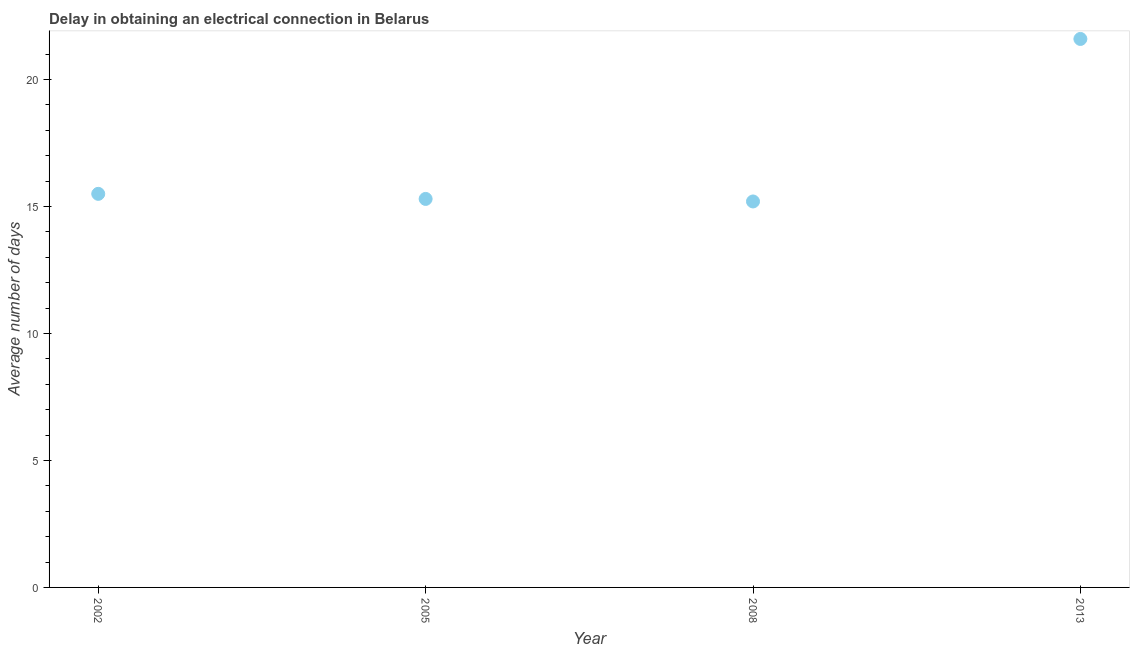Across all years, what is the maximum dalay in electrical connection?
Provide a succinct answer. 21.6. What is the sum of the dalay in electrical connection?
Your answer should be compact. 67.6. What is the difference between the dalay in electrical connection in 2008 and 2013?
Give a very brief answer. -6.4. Do a majority of the years between 2013 and 2008 (inclusive) have dalay in electrical connection greater than 6 days?
Provide a succinct answer. No. What is the ratio of the dalay in electrical connection in 2002 to that in 2008?
Your answer should be compact. 1.02. Is the dalay in electrical connection in 2002 less than that in 2008?
Ensure brevity in your answer.  No. Is the difference between the dalay in electrical connection in 2005 and 2013 greater than the difference between any two years?
Offer a terse response. No. What is the difference between the highest and the second highest dalay in electrical connection?
Provide a succinct answer. 6.1. What is the difference between the highest and the lowest dalay in electrical connection?
Keep it short and to the point. 6.4. Does the dalay in electrical connection monotonically increase over the years?
Make the answer very short. No. How many years are there in the graph?
Provide a succinct answer. 4. Does the graph contain grids?
Your response must be concise. No. What is the title of the graph?
Provide a succinct answer. Delay in obtaining an electrical connection in Belarus. What is the label or title of the X-axis?
Give a very brief answer. Year. What is the label or title of the Y-axis?
Give a very brief answer. Average number of days. What is the Average number of days in 2005?
Ensure brevity in your answer.  15.3. What is the Average number of days in 2008?
Give a very brief answer. 15.2. What is the Average number of days in 2013?
Offer a terse response. 21.6. What is the difference between the Average number of days in 2002 and 2005?
Offer a terse response. 0.2. What is the difference between the Average number of days in 2005 and 2008?
Provide a succinct answer. 0.1. What is the difference between the Average number of days in 2005 and 2013?
Offer a terse response. -6.3. What is the ratio of the Average number of days in 2002 to that in 2008?
Your answer should be compact. 1.02. What is the ratio of the Average number of days in 2002 to that in 2013?
Ensure brevity in your answer.  0.72. What is the ratio of the Average number of days in 2005 to that in 2013?
Make the answer very short. 0.71. What is the ratio of the Average number of days in 2008 to that in 2013?
Your answer should be very brief. 0.7. 